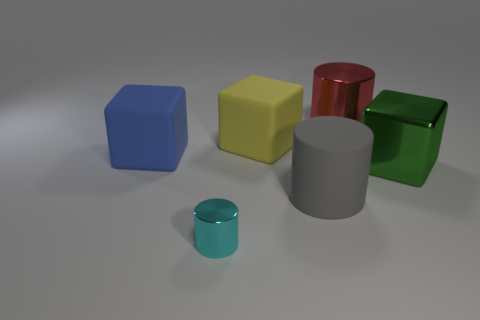Subtract all rubber cubes. How many cubes are left? 1 Add 4 big purple cylinders. How many objects exist? 10 Subtract all cyan blocks. Subtract all purple cylinders. How many blocks are left? 3 Add 6 big blue things. How many big blue things exist? 7 Subtract 0 purple blocks. How many objects are left? 6 Subtract all big yellow metallic spheres. Subtract all large cylinders. How many objects are left? 4 Add 5 red things. How many red things are left? 6 